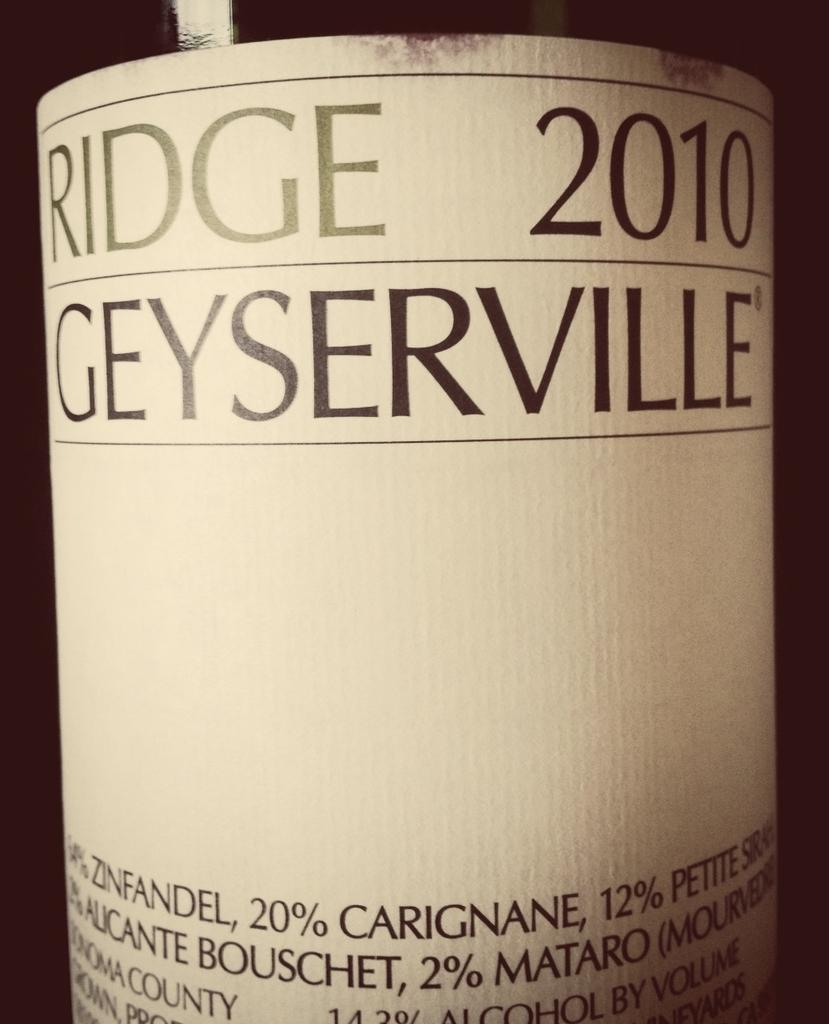<image>
Provide a brief description of the given image. A close up of the label of a bottle of Ridge 2010 wine. 